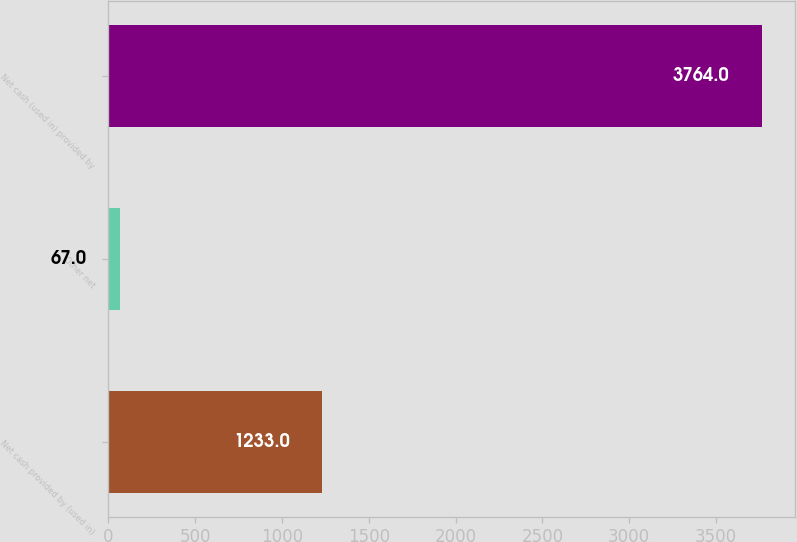Convert chart to OTSL. <chart><loc_0><loc_0><loc_500><loc_500><bar_chart><fcel>Net cash provided by (used in)<fcel>Other net<fcel>Net cash (used in) provided by<nl><fcel>1233<fcel>67<fcel>3764<nl></chart> 